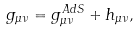<formula> <loc_0><loc_0><loc_500><loc_500>g _ { \mu \nu } = g _ { \mu \nu } ^ { A d S } + h _ { \mu \nu } ,</formula> 